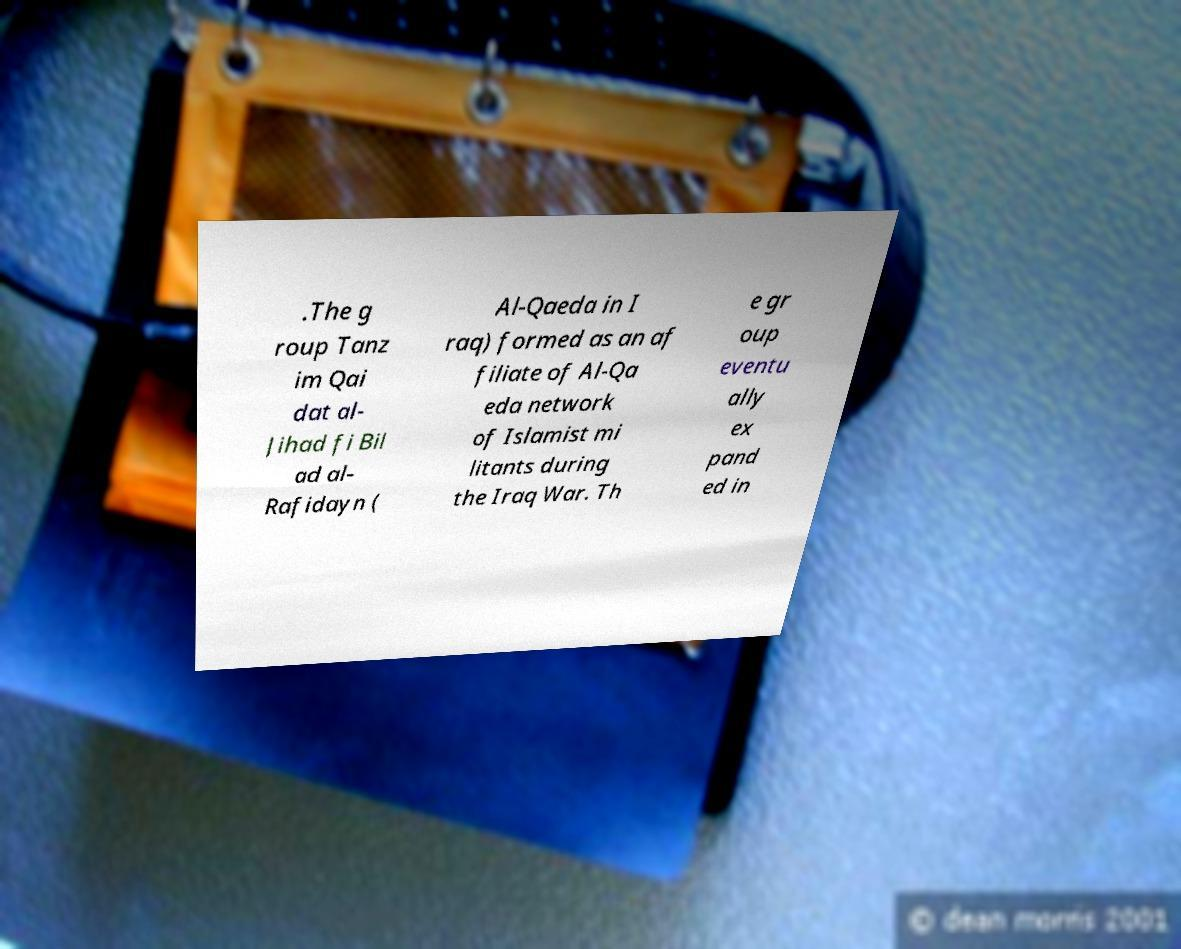Can you accurately transcribe the text from the provided image for me? .The g roup Tanz im Qai dat al- Jihad fi Bil ad al- Rafidayn ( Al-Qaeda in I raq) formed as an af filiate of Al-Qa eda network of Islamist mi litants during the Iraq War. Th e gr oup eventu ally ex pand ed in 